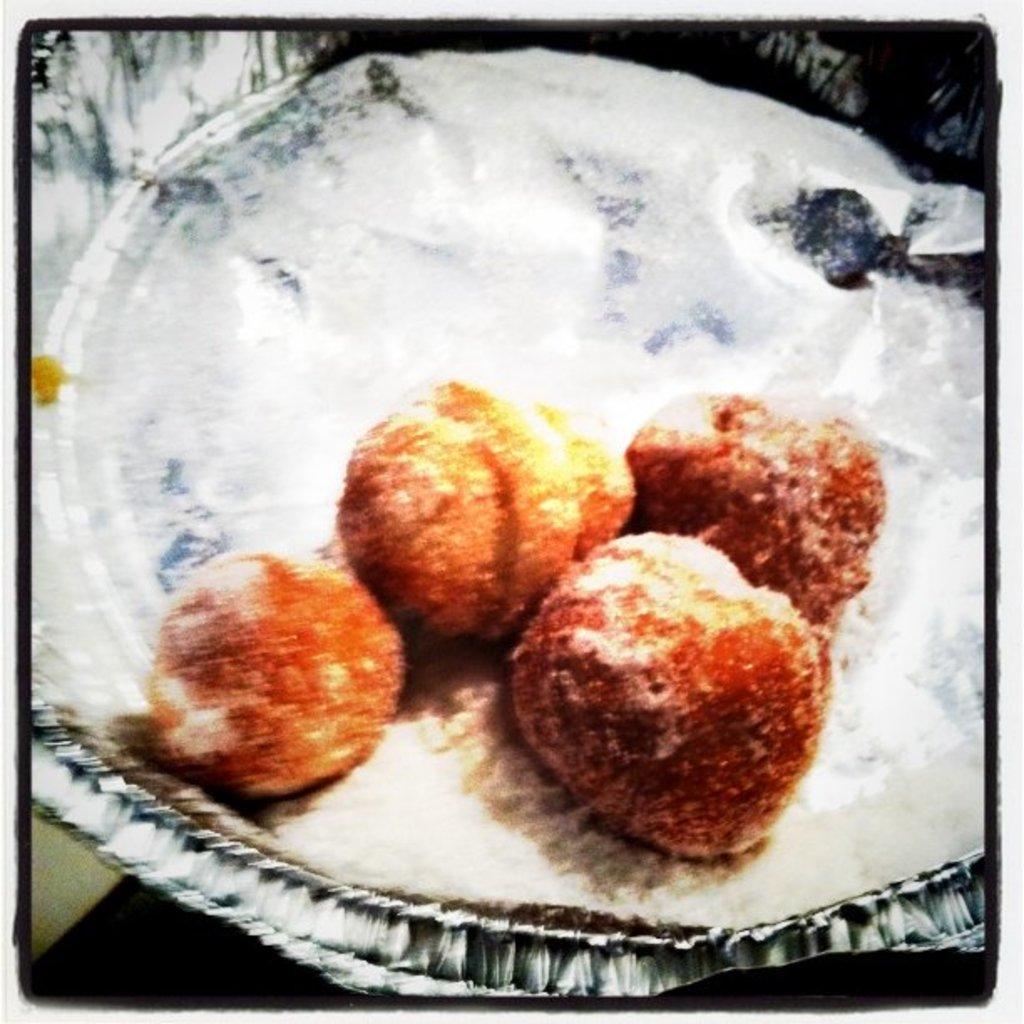Please provide a concise description of this image. In this image, I can see a paper plate with a food item on it. 